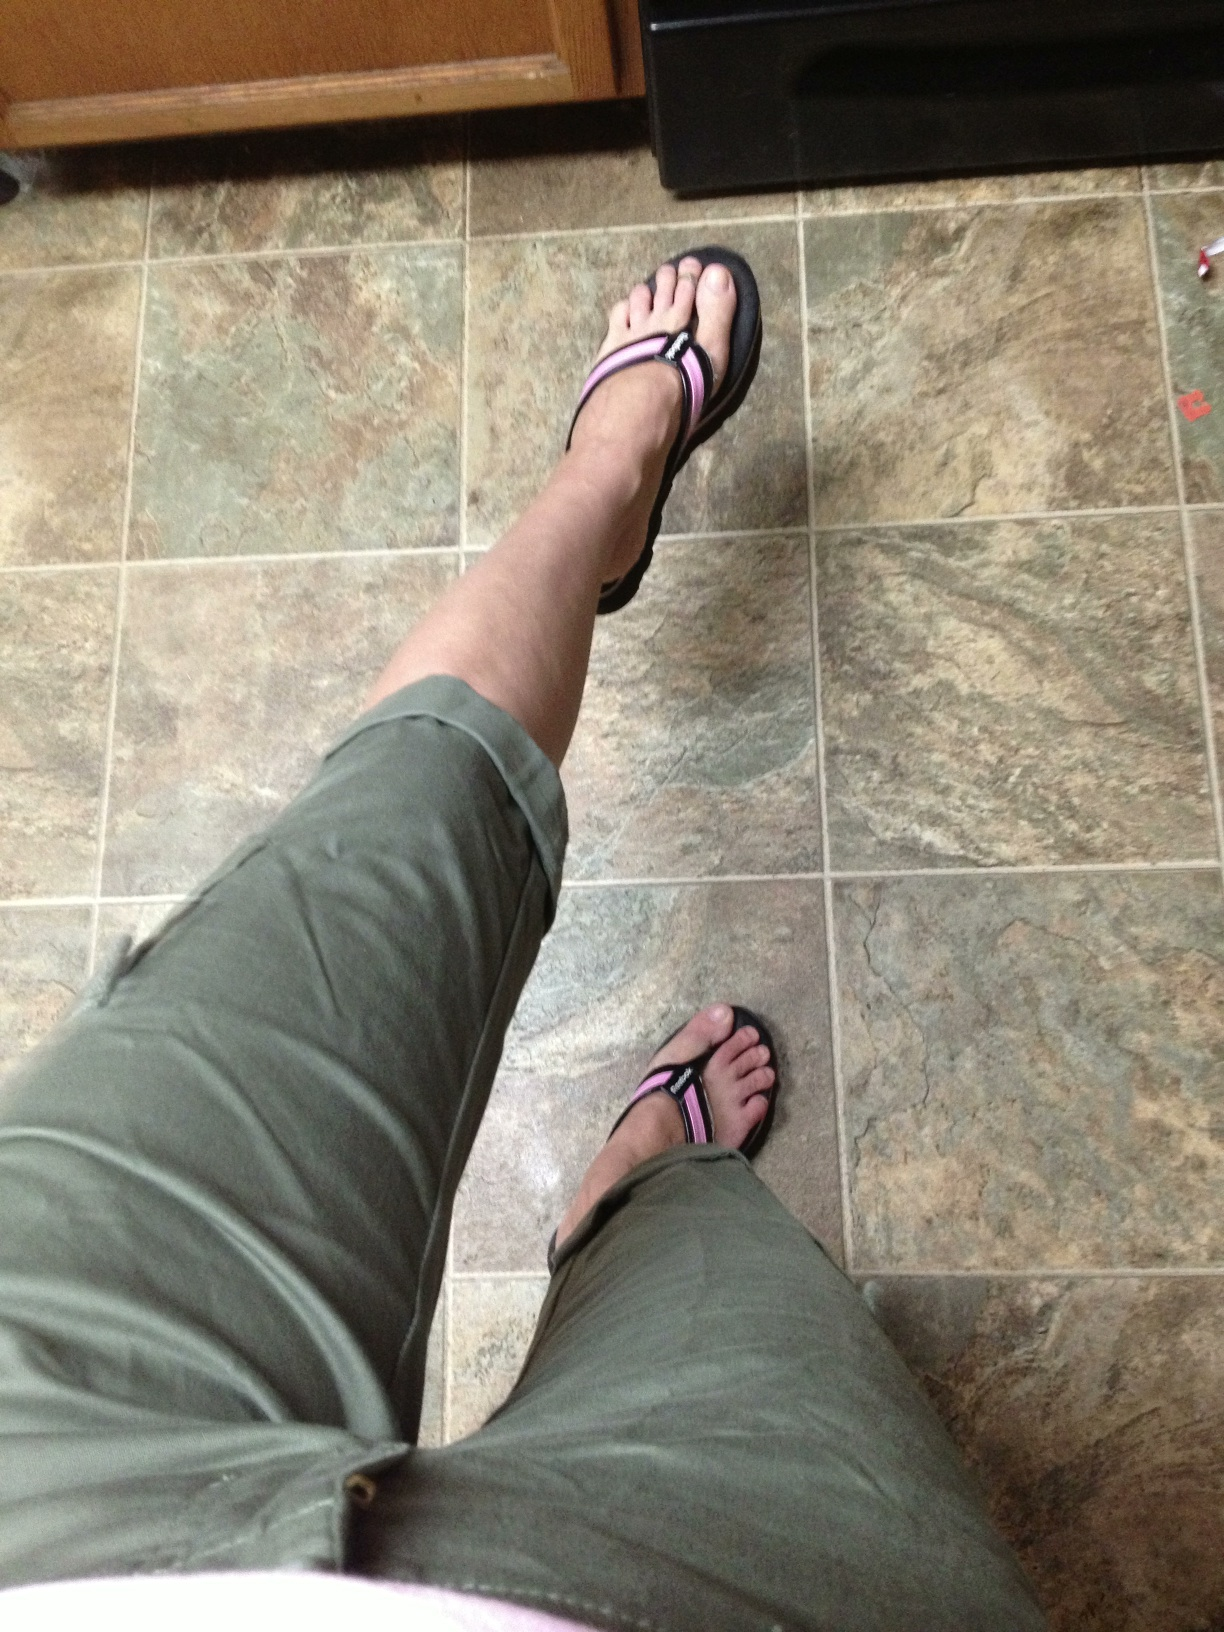Can you tell me what color the pants are that I'm wearing? They're just below the knee. I can't tell if they're- well I just don't know what color they are. from Vizwiz green 